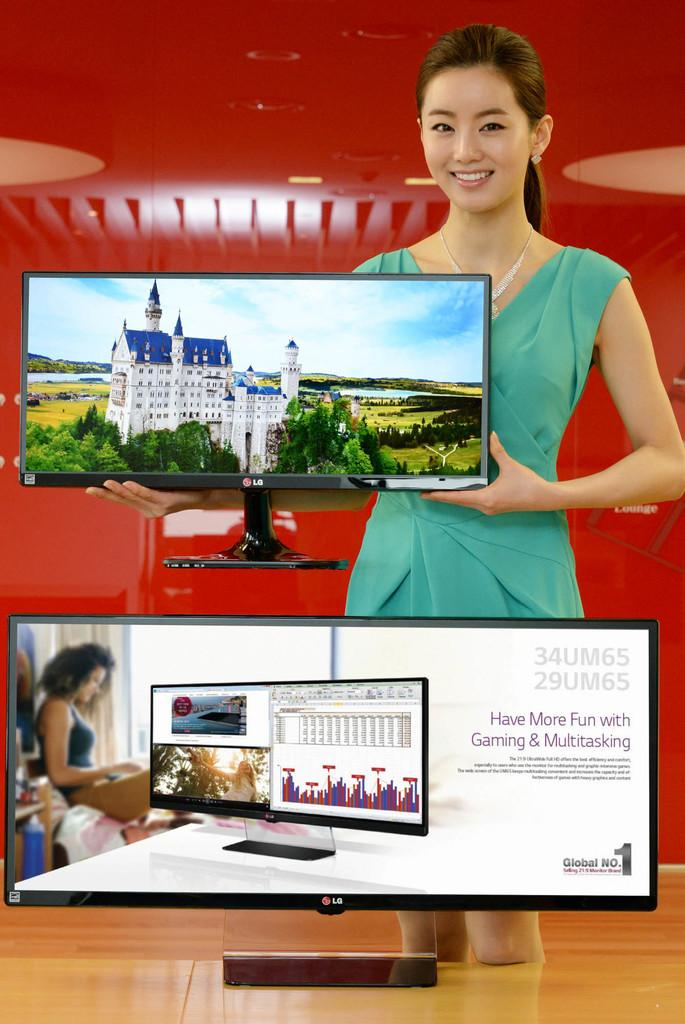<image>
Give a short and clear explanation of the subsequent image. a woman displaying two LG monitors and red backdrop 